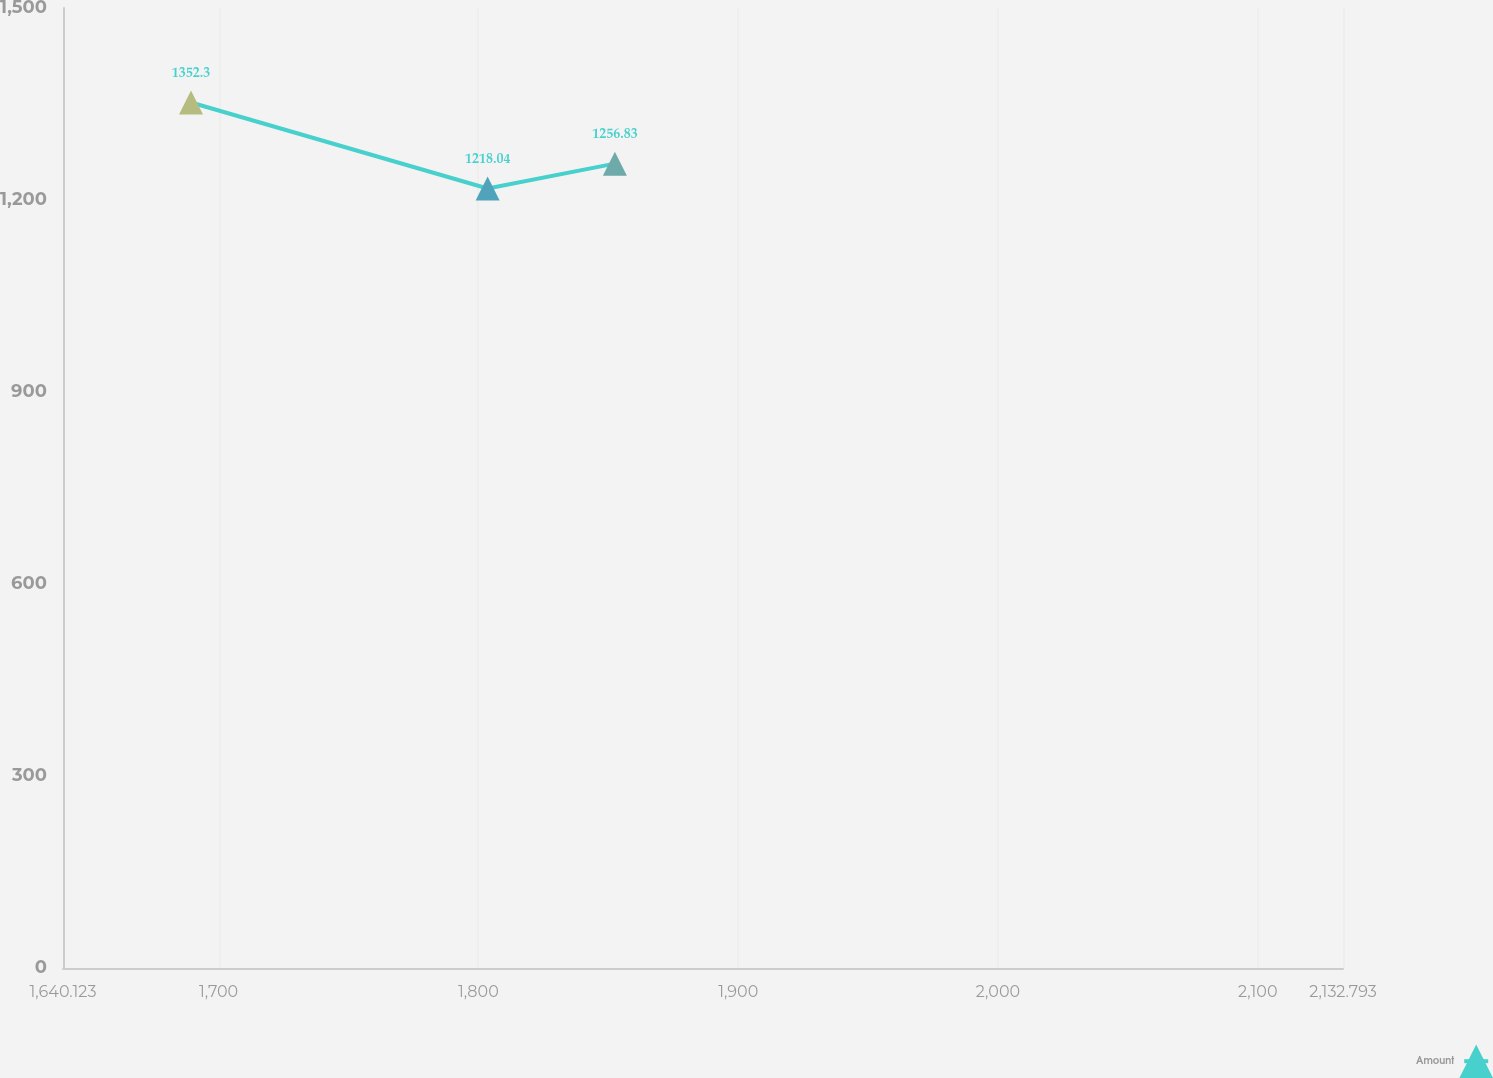Convert chart to OTSL. <chart><loc_0><loc_0><loc_500><loc_500><line_chart><ecel><fcel>Amount<nl><fcel>1689.39<fcel>1352.3<nl><fcel>1803.57<fcel>1218.04<nl><fcel>1852.54<fcel>1256.83<nl><fcel>2133.09<fcel>1621.56<nl><fcel>2182.06<fcel>1582.77<nl></chart> 